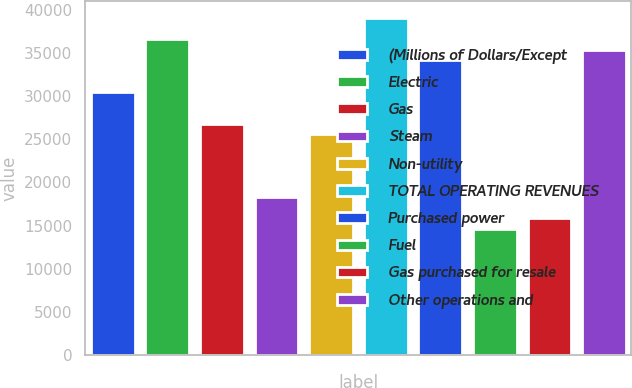Convert chart to OTSL. <chart><loc_0><loc_0><loc_500><loc_500><bar_chart><fcel>(Millions of Dollars/Except<fcel>Electric<fcel>Gas<fcel>Steam<fcel>Non-utility<fcel>TOTAL OPERATING REVENUES<fcel>Purchased power<fcel>Fuel<fcel>Gas purchased for resale<fcel>Other operations and<nl><fcel>30467<fcel>36560<fcel>26811.2<fcel>18281<fcel>25592.6<fcel>38997.2<fcel>34122.8<fcel>14625.2<fcel>15843.8<fcel>35341.4<nl></chart> 